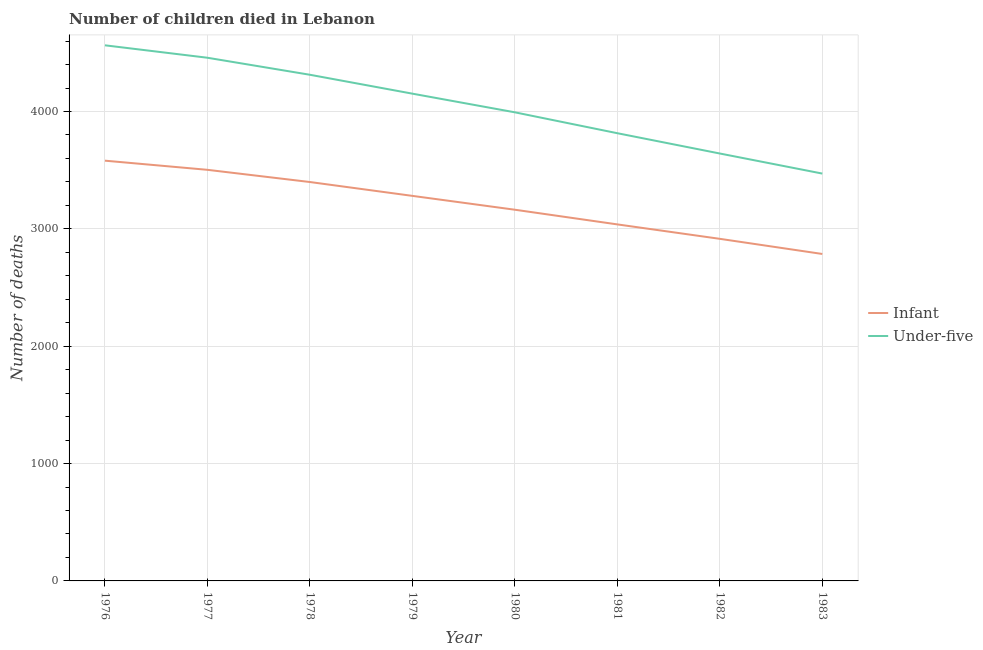Does the line corresponding to number of under-five deaths intersect with the line corresponding to number of infant deaths?
Make the answer very short. No. Is the number of lines equal to the number of legend labels?
Provide a succinct answer. Yes. What is the number of infant deaths in 1978?
Make the answer very short. 3399. Across all years, what is the maximum number of under-five deaths?
Your answer should be very brief. 4564. Across all years, what is the minimum number of under-five deaths?
Your answer should be compact. 3471. In which year was the number of under-five deaths maximum?
Offer a terse response. 1976. What is the total number of under-five deaths in the graph?
Provide a short and direct response. 3.24e+04. What is the difference between the number of under-five deaths in 1979 and that in 1982?
Offer a terse response. 510. What is the difference between the number of under-five deaths in 1979 and the number of infant deaths in 1977?
Give a very brief answer. 649. What is the average number of infant deaths per year?
Give a very brief answer. 3208.25. In the year 1980, what is the difference between the number of infant deaths and number of under-five deaths?
Give a very brief answer. -830. In how many years, is the number of under-five deaths greater than 600?
Keep it short and to the point. 8. What is the ratio of the number of under-five deaths in 1981 to that in 1982?
Give a very brief answer. 1.05. Is the number of infant deaths in 1979 less than that in 1982?
Offer a very short reply. No. What is the difference between the highest and the second highest number of under-five deaths?
Your answer should be compact. 106. What is the difference between the highest and the lowest number of infant deaths?
Provide a short and direct response. 795. In how many years, is the number of infant deaths greater than the average number of infant deaths taken over all years?
Offer a terse response. 4. Is the number of under-five deaths strictly greater than the number of infant deaths over the years?
Give a very brief answer. Yes. How many years are there in the graph?
Provide a short and direct response. 8. What is the difference between two consecutive major ticks on the Y-axis?
Provide a short and direct response. 1000. Does the graph contain any zero values?
Your answer should be very brief. No. Where does the legend appear in the graph?
Give a very brief answer. Center right. How are the legend labels stacked?
Keep it short and to the point. Vertical. What is the title of the graph?
Provide a short and direct response. Number of children died in Lebanon. What is the label or title of the X-axis?
Give a very brief answer. Year. What is the label or title of the Y-axis?
Offer a terse response. Number of deaths. What is the Number of deaths of Infant in 1976?
Keep it short and to the point. 3581. What is the Number of deaths in Under-five in 1976?
Ensure brevity in your answer.  4564. What is the Number of deaths of Infant in 1977?
Offer a very short reply. 3503. What is the Number of deaths in Under-five in 1977?
Your answer should be very brief. 4458. What is the Number of deaths of Infant in 1978?
Give a very brief answer. 3399. What is the Number of deaths of Under-five in 1978?
Keep it short and to the point. 4313. What is the Number of deaths of Infant in 1979?
Ensure brevity in your answer.  3281. What is the Number of deaths of Under-five in 1979?
Offer a terse response. 4152. What is the Number of deaths of Infant in 1980?
Your response must be concise. 3163. What is the Number of deaths of Under-five in 1980?
Keep it short and to the point. 3993. What is the Number of deaths of Infant in 1981?
Keep it short and to the point. 3038. What is the Number of deaths of Under-five in 1981?
Provide a succinct answer. 3815. What is the Number of deaths in Infant in 1982?
Give a very brief answer. 2915. What is the Number of deaths in Under-five in 1982?
Your answer should be very brief. 3642. What is the Number of deaths of Infant in 1983?
Your response must be concise. 2786. What is the Number of deaths of Under-five in 1983?
Provide a succinct answer. 3471. Across all years, what is the maximum Number of deaths of Infant?
Your response must be concise. 3581. Across all years, what is the maximum Number of deaths of Under-five?
Give a very brief answer. 4564. Across all years, what is the minimum Number of deaths of Infant?
Provide a short and direct response. 2786. Across all years, what is the minimum Number of deaths of Under-five?
Keep it short and to the point. 3471. What is the total Number of deaths of Infant in the graph?
Provide a succinct answer. 2.57e+04. What is the total Number of deaths of Under-five in the graph?
Provide a succinct answer. 3.24e+04. What is the difference between the Number of deaths of Under-five in 1976 and that in 1977?
Provide a short and direct response. 106. What is the difference between the Number of deaths of Infant in 1976 and that in 1978?
Offer a terse response. 182. What is the difference between the Number of deaths of Under-five in 1976 and that in 1978?
Ensure brevity in your answer.  251. What is the difference between the Number of deaths of Infant in 1976 and that in 1979?
Ensure brevity in your answer.  300. What is the difference between the Number of deaths in Under-five in 1976 and that in 1979?
Keep it short and to the point. 412. What is the difference between the Number of deaths of Infant in 1976 and that in 1980?
Offer a very short reply. 418. What is the difference between the Number of deaths of Under-five in 1976 and that in 1980?
Give a very brief answer. 571. What is the difference between the Number of deaths of Infant in 1976 and that in 1981?
Give a very brief answer. 543. What is the difference between the Number of deaths in Under-five in 1976 and that in 1981?
Provide a succinct answer. 749. What is the difference between the Number of deaths in Infant in 1976 and that in 1982?
Your response must be concise. 666. What is the difference between the Number of deaths of Under-five in 1976 and that in 1982?
Make the answer very short. 922. What is the difference between the Number of deaths of Infant in 1976 and that in 1983?
Provide a short and direct response. 795. What is the difference between the Number of deaths of Under-five in 1976 and that in 1983?
Provide a short and direct response. 1093. What is the difference between the Number of deaths in Infant in 1977 and that in 1978?
Offer a terse response. 104. What is the difference between the Number of deaths of Under-five in 1977 and that in 1978?
Keep it short and to the point. 145. What is the difference between the Number of deaths of Infant in 1977 and that in 1979?
Your answer should be very brief. 222. What is the difference between the Number of deaths in Under-five in 1977 and that in 1979?
Make the answer very short. 306. What is the difference between the Number of deaths of Infant in 1977 and that in 1980?
Make the answer very short. 340. What is the difference between the Number of deaths in Under-five in 1977 and that in 1980?
Offer a very short reply. 465. What is the difference between the Number of deaths of Infant in 1977 and that in 1981?
Give a very brief answer. 465. What is the difference between the Number of deaths of Under-five in 1977 and that in 1981?
Offer a very short reply. 643. What is the difference between the Number of deaths of Infant in 1977 and that in 1982?
Your answer should be very brief. 588. What is the difference between the Number of deaths in Under-five in 1977 and that in 1982?
Provide a succinct answer. 816. What is the difference between the Number of deaths in Infant in 1977 and that in 1983?
Make the answer very short. 717. What is the difference between the Number of deaths in Under-five in 1977 and that in 1983?
Provide a succinct answer. 987. What is the difference between the Number of deaths in Infant in 1978 and that in 1979?
Provide a short and direct response. 118. What is the difference between the Number of deaths in Under-five in 1978 and that in 1979?
Make the answer very short. 161. What is the difference between the Number of deaths in Infant in 1978 and that in 1980?
Ensure brevity in your answer.  236. What is the difference between the Number of deaths of Under-five in 1978 and that in 1980?
Give a very brief answer. 320. What is the difference between the Number of deaths of Infant in 1978 and that in 1981?
Offer a very short reply. 361. What is the difference between the Number of deaths of Under-five in 1978 and that in 1981?
Give a very brief answer. 498. What is the difference between the Number of deaths of Infant in 1978 and that in 1982?
Your answer should be compact. 484. What is the difference between the Number of deaths of Under-five in 1978 and that in 1982?
Offer a very short reply. 671. What is the difference between the Number of deaths in Infant in 1978 and that in 1983?
Make the answer very short. 613. What is the difference between the Number of deaths of Under-five in 1978 and that in 1983?
Offer a terse response. 842. What is the difference between the Number of deaths in Infant in 1979 and that in 1980?
Provide a succinct answer. 118. What is the difference between the Number of deaths in Under-five in 1979 and that in 1980?
Make the answer very short. 159. What is the difference between the Number of deaths of Infant in 1979 and that in 1981?
Your answer should be very brief. 243. What is the difference between the Number of deaths of Under-five in 1979 and that in 1981?
Make the answer very short. 337. What is the difference between the Number of deaths of Infant in 1979 and that in 1982?
Ensure brevity in your answer.  366. What is the difference between the Number of deaths in Under-five in 1979 and that in 1982?
Offer a very short reply. 510. What is the difference between the Number of deaths of Infant in 1979 and that in 1983?
Your answer should be compact. 495. What is the difference between the Number of deaths in Under-five in 1979 and that in 1983?
Keep it short and to the point. 681. What is the difference between the Number of deaths in Infant in 1980 and that in 1981?
Your answer should be very brief. 125. What is the difference between the Number of deaths in Under-five in 1980 and that in 1981?
Keep it short and to the point. 178. What is the difference between the Number of deaths in Infant in 1980 and that in 1982?
Offer a very short reply. 248. What is the difference between the Number of deaths in Under-five in 1980 and that in 1982?
Keep it short and to the point. 351. What is the difference between the Number of deaths of Infant in 1980 and that in 1983?
Give a very brief answer. 377. What is the difference between the Number of deaths in Under-five in 1980 and that in 1983?
Your answer should be very brief. 522. What is the difference between the Number of deaths of Infant in 1981 and that in 1982?
Offer a very short reply. 123. What is the difference between the Number of deaths in Under-five in 1981 and that in 1982?
Provide a succinct answer. 173. What is the difference between the Number of deaths in Infant in 1981 and that in 1983?
Provide a short and direct response. 252. What is the difference between the Number of deaths in Under-five in 1981 and that in 1983?
Give a very brief answer. 344. What is the difference between the Number of deaths of Infant in 1982 and that in 1983?
Your response must be concise. 129. What is the difference between the Number of deaths in Under-five in 1982 and that in 1983?
Make the answer very short. 171. What is the difference between the Number of deaths of Infant in 1976 and the Number of deaths of Under-five in 1977?
Ensure brevity in your answer.  -877. What is the difference between the Number of deaths of Infant in 1976 and the Number of deaths of Under-five in 1978?
Your response must be concise. -732. What is the difference between the Number of deaths of Infant in 1976 and the Number of deaths of Under-five in 1979?
Offer a very short reply. -571. What is the difference between the Number of deaths in Infant in 1976 and the Number of deaths in Under-five in 1980?
Provide a short and direct response. -412. What is the difference between the Number of deaths of Infant in 1976 and the Number of deaths of Under-five in 1981?
Make the answer very short. -234. What is the difference between the Number of deaths of Infant in 1976 and the Number of deaths of Under-five in 1982?
Keep it short and to the point. -61. What is the difference between the Number of deaths in Infant in 1976 and the Number of deaths in Under-five in 1983?
Make the answer very short. 110. What is the difference between the Number of deaths of Infant in 1977 and the Number of deaths of Under-five in 1978?
Offer a very short reply. -810. What is the difference between the Number of deaths in Infant in 1977 and the Number of deaths in Under-five in 1979?
Keep it short and to the point. -649. What is the difference between the Number of deaths in Infant in 1977 and the Number of deaths in Under-five in 1980?
Provide a succinct answer. -490. What is the difference between the Number of deaths of Infant in 1977 and the Number of deaths of Under-five in 1981?
Your answer should be compact. -312. What is the difference between the Number of deaths in Infant in 1977 and the Number of deaths in Under-five in 1982?
Ensure brevity in your answer.  -139. What is the difference between the Number of deaths of Infant in 1977 and the Number of deaths of Under-five in 1983?
Provide a short and direct response. 32. What is the difference between the Number of deaths in Infant in 1978 and the Number of deaths in Under-five in 1979?
Offer a terse response. -753. What is the difference between the Number of deaths of Infant in 1978 and the Number of deaths of Under-five in 1980?
Provide a short and direct response. -594. What is the difference between the Number of deaths in Infant in 1978 and the Number of deaths in Under-five in 1981?
Provide a short and direct response. -416. What is the difference between the Number of deaths of Infant in 1978 and the Number of deaths of Under-five in 1982?
Keep it short and to the point. -243. What is the difference between the Number of deaths of Infant in 1978 and the Number of deaths of Under-five in 1983?
Provide a succinct answer. -72. What is the difference between the Number of deaths in Infant in 1979 and the Number of deaths in Under-five in 1980?
Your answer should be very brief. -712. What is the difference between the Number of deaths of Infant in 1979 and the Number of deaths of Under-five in 1981?
Give a very brief answer. -534. What is the difference between the Number of deaths of Infant in 1979 and the Number of deaths of Under-five in 1982?
Give a very brief answer. -361. What is the difference between the Number of deaths in Infant in 1979 and the Number of deaths in Under-five in 1983?
Your response must be concise. -190. What is the difference between the Number of deaths of Infant in 1980 and the Number of deaths of Under-five in 1981?
Your response must be concise. -652. What is the difference between the Number of deaths of Infant in 1980 and the Number of deaths of Under-five in 1982?
Provide a short and direct response. -479. What is the difference between the Number of deaths of Infant in 1980 and the Number of deaths of Under-five in 1983?
Ensure brevity in your answer.  -308. What is the difference between the Number of deaths in Infant in 1981 and the Number of deaths in Under-five in 1982?
Offer a very short reply. -604. What is the difference between the Number of deaths in Infant in 1981 and the Number of deaths in Under-five in 1983?
Provide a succinct answer. -433. What is the difference between the Number of deaths of Infant in 1982 and the Number of deaths of Under-five in 1983?
Provide a succinct answer. -556. What is the average Number of deaths in Infant per year?
Keep it short and to the point. 3208.25. What is the average Number of deaths of Under-five per year?
Ensure brevity in your answer.  4051. In the year 1976, what is the difference between the Number of deaths in Infant and Number of deaths in Under-five?
Your answer should be compact. -983. In the year 1977, what is the difference between the Number of deaths in Infant and Number of deaths in Under-five?
Your answer should be very brief. -955. In the year 1978, what is the difference between the Number of deaths in Infant and Number of deaths in Under-five?
Make the answer very short. -914. In the year 1979, what is the difference between the Number of deaths of Infant and Number of deaths of Under-five?
Your answer should be very brief. -871. In the year 1980, what is the difference between the Number of deaths in Infant and Number of deaths in Under-five?
Provide a short and direct response. -830. In the year 1981, what is the difference between the Number of deaths of Infant and Number of deaths of Under-five?
Your response must be concise. -777. In the year 1982, what is the difference between the Number of deaths of Infant and Number of deaths of Under-five?
Offer a very short reply. -727. In the year 1983, what is the difference between the Number of deaths of Infant and Number of deaths of Under-five?
Ensure brevity in your answer.  -685. What is the ratio of the Number of deaths in Infant in 1976 to that in 1977?
Provide a short and direct response. 1.02. What is the ratio of the Number of deaths of Under-five in 1976 to that in 1977?
Provide a succinct answer. 1.02. What is the ratio of the Number of deaths in Infant in 1976 to that in 1978?
Provide a succinct answer. 1.05. What is the ratio of the Number of deaths of Under-five in 1976 to that in 1978?
Offer a terse response. 1.06. What is the ratio of the Number of deaths of Infant in 1976 to that in 1979?
Provide a succinct answer. 1.09. What is the ratio of the Number of deaths in Under-five in 1976 to that in 1979?
Offer a very short reply. 1.1. What is the ratio of the Number of deaths in Infant in 1976 to that in 1980?
Your response must be concise. 1.13. What is the ratio of the Number of deaths in Under-five in 1976 to that in 1980?
Provide a short and direct response. 1.14. What is the ratio of the Number of deaths of Infant in 1976 to that in 1981?
Keep it short and to the point. 1.18. What is the ratio of the Number of deaths in Under-five in 1976 to that in 1981?
Give a very brief answer. 1.2. What is the ratio of the Number of deaths of Infant in 1976 to that in 1982?
Your answer should be compact. 1.23. What is the ratio of the Number of deaths in Under-five in 1976 to that in 1982?
Offer a very short reply. 1.25. What is the ratio of the Number of deaths in Infant in 1976 to that in 1983?
Your answer should be very brief. 1.29. What is the ratio of the Number of deaths in Under-five in 1976 to that in 1983?
Your response must be concise. 1.31. What is the ratio of the Number of deaths of Infant in 1977 to that in 1978?
Provide a succinct answer. 1.03. What is the ratio of the Number of deaths in Under-five in 1977 to that in 1978?
Offer a terse response. 1.03. What is the ratio of the Number of deaths in Infant in 1977 to that in 1979?
Give a very brief answer. 1.07. What is the ratio of the Number of deaths in Under-five in 1977 to that in 1979?
Your answer should be very brief. 1.07. What is the ratio of the Number of deaths of Infant in 1977 to that in 1980?
Provide a succinct answer. 1.11. What is the ratio of the Number of deaths of Under-five in 1977 to that in 1980?
Your answer should be compact. 1.12. What is the ratio of the Number of deaths of Infant in 1977 to that in 1981?
Keep it short and to the point. 1.15. What is the ratio of the Number of deaths of Under-five in 1977 to that in 1981?
Give a very brief answer. 1.17. What is the ratio of the Number of deaths in Infant in 1977 to that in 1982?
Offer a very short reply. 1.2. What is the ratio of the Number of deaths in Under-five in 1977 to that in 1982?
Provide a short and direct response. 1.22. What is the ratio of the Number of deaths in Infant in 1977 to that in 1983?
Your answer should be compact. 1.26. What is the ratio of the Number of deaths in Under-five in 1977 to that in 1983?
Provide a succinct answer. 1.28. What is the ratio of the Number of deaths in Infant in 1978 to that in 1979?
Provide a short and direct response. 1.04. What is the ratio of the Number of deaths of Under-five in 1978 to that in 1979?
Your response must be concise. 1.04. What is the ratio of the Number of deaths of Infant in 1978 to that in 1980?
Give a very brief answer. 1.07. What is the ratio of the Number of deaths of Under-five in 1978 to that in 1980?
Your response must be concise. 1.08. What is the ratio of the Number of deaths of Infant in 1978 to that in 1981?
Your answer should be compact. 1.12. What is the ratio of the Number of deaths of Under-five in 1978 to that in 1981?
Your answer should be very brief. 1.13. What is the ratio of the Number of deaths of Infant in 1978 to that in 1982?
Offer a terse response. 1.17. What is the ratio of the Number of deaths in Under-five in 1978 to that in 1982?
Offer a terse response. 1.18. What is the ratio of the Number of deaths in Infant in 1978 to that in 1983?
Offer a very short reply. 1.22. What is the ratio of the Number of deaths in Under-five in 1978 to that in 1983?
Make the answer very short. 1.24. What is the ratio of the Number of deaths of Infant in 1979 to that in 1980?
Offer a terse response. 1.04. What is the ratio of the Number of deaths in Under-five in 1979 to that in 1980?
Make the answer very short. 1.04. What is the ratio of the Number of deaths of Under-five in 1979 to that in 1981?
Your response must be concise. 1.09. What is the ratio of the Number of deaths in Infant in 1979 to that in 1982?
Your response must be concise. 1.13. What is the ratio of the Number of deaths of Under-five in 1979 to that in 1982?
Make the answer very short. 1.14. What is the ratio of the Number of deaths in Infant in 1979 to that in 1983?
Offer a very short reply. 1.18. What is the ratio of the Number of deaths in Under-five in 1979 to that in 1983?
Provide a short and direct response. 1.2. What is the ratio of the Number of deaths in Infant in 1980 to that in 1981?
Provide a succinct answer. 1.04. What is the ratio of the Number of deaths of Under-five in 1980 to that in 1981?
Offer a terse response. 1.05. What is the ratio of the Number of deaths of Infant in 1980 to that in 1982?
Keep it short and to the point. 1.09. What is the ratio of the Number of deaths of Under-five in 1980 to that in 1982?
Provide a succinct answer. 1.1. What is the ratio of the Number of deaths in Infant in 1980 to that in 1983?
Ensure brevity in your answer.  1.14. What is the ratio of the Number of deaths of Under-five in 1980 to that in 1983?
Keep it short and to the point. 1.15. What is the ratio of the Number of deaths of Infant in 1981 to that in 1982?
Make the answer very short. 1.04. What is the ratio of the Number of deaths of Under-five in 1981 to that in 1982?
Ensure brevity in your answer.  1.05. What is the ratio of the Number of deaths of Infant in 1981 to that in 1983?
Your answer should be very brief. 1.09. What is the ratio of the Number of deaths of Under-five in 1981 to that in 1983?
Your answer should be very brief. 1.1. What is the ratio of the Number of deaths in Infant in 1982 to that in 1983?
Provide a short and direct response. 1.05. What is the ratio of the Number of deaths in Under-five in 1982 to that in 1983?
Make the answer very short. 1.05. What is the difference between the highest and the second highest Number of deaths in Under-five?
Your answer should be very brief. 106. What is the difference between the highest and the lowest Number of deaths in Infant?
Offer a very short reply. 795. What is the difference between the highest and the lowest Number of deaths in Under-five?
Offer a terse response. 1093. 